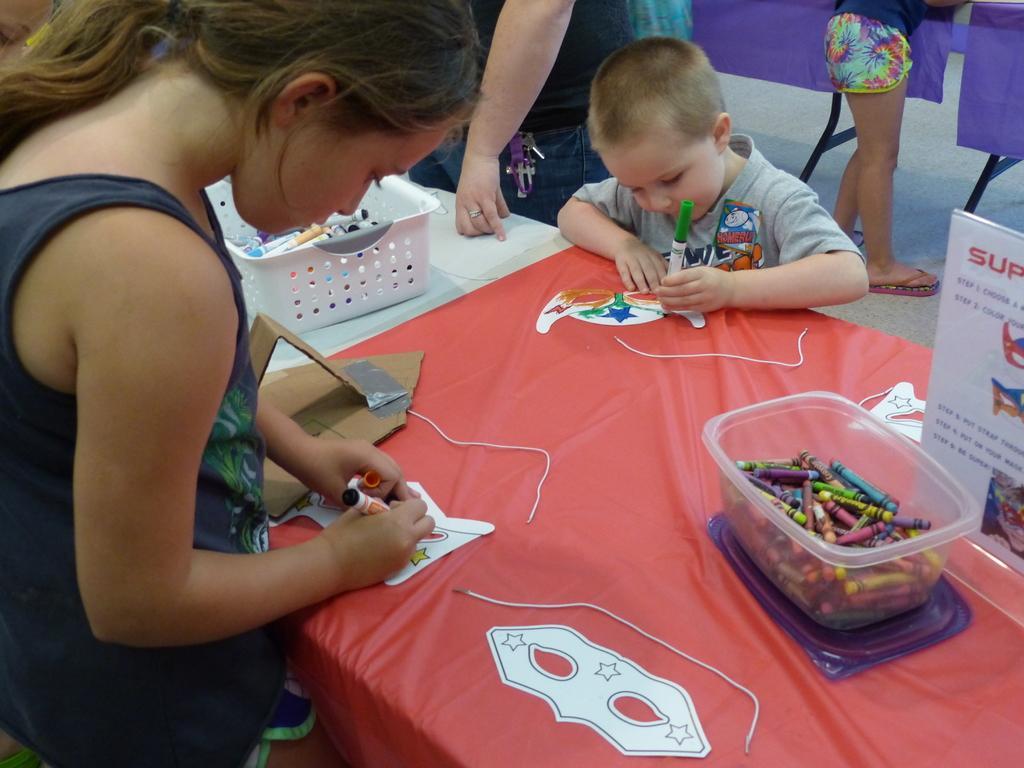How would you summarize this image in a sentence or two? In this image, we can see a table, on that table there is a white color plastic box kept, in that box there are some color pencils kept, there are some kids standing and they are coloring, in the background there is a person standing. 